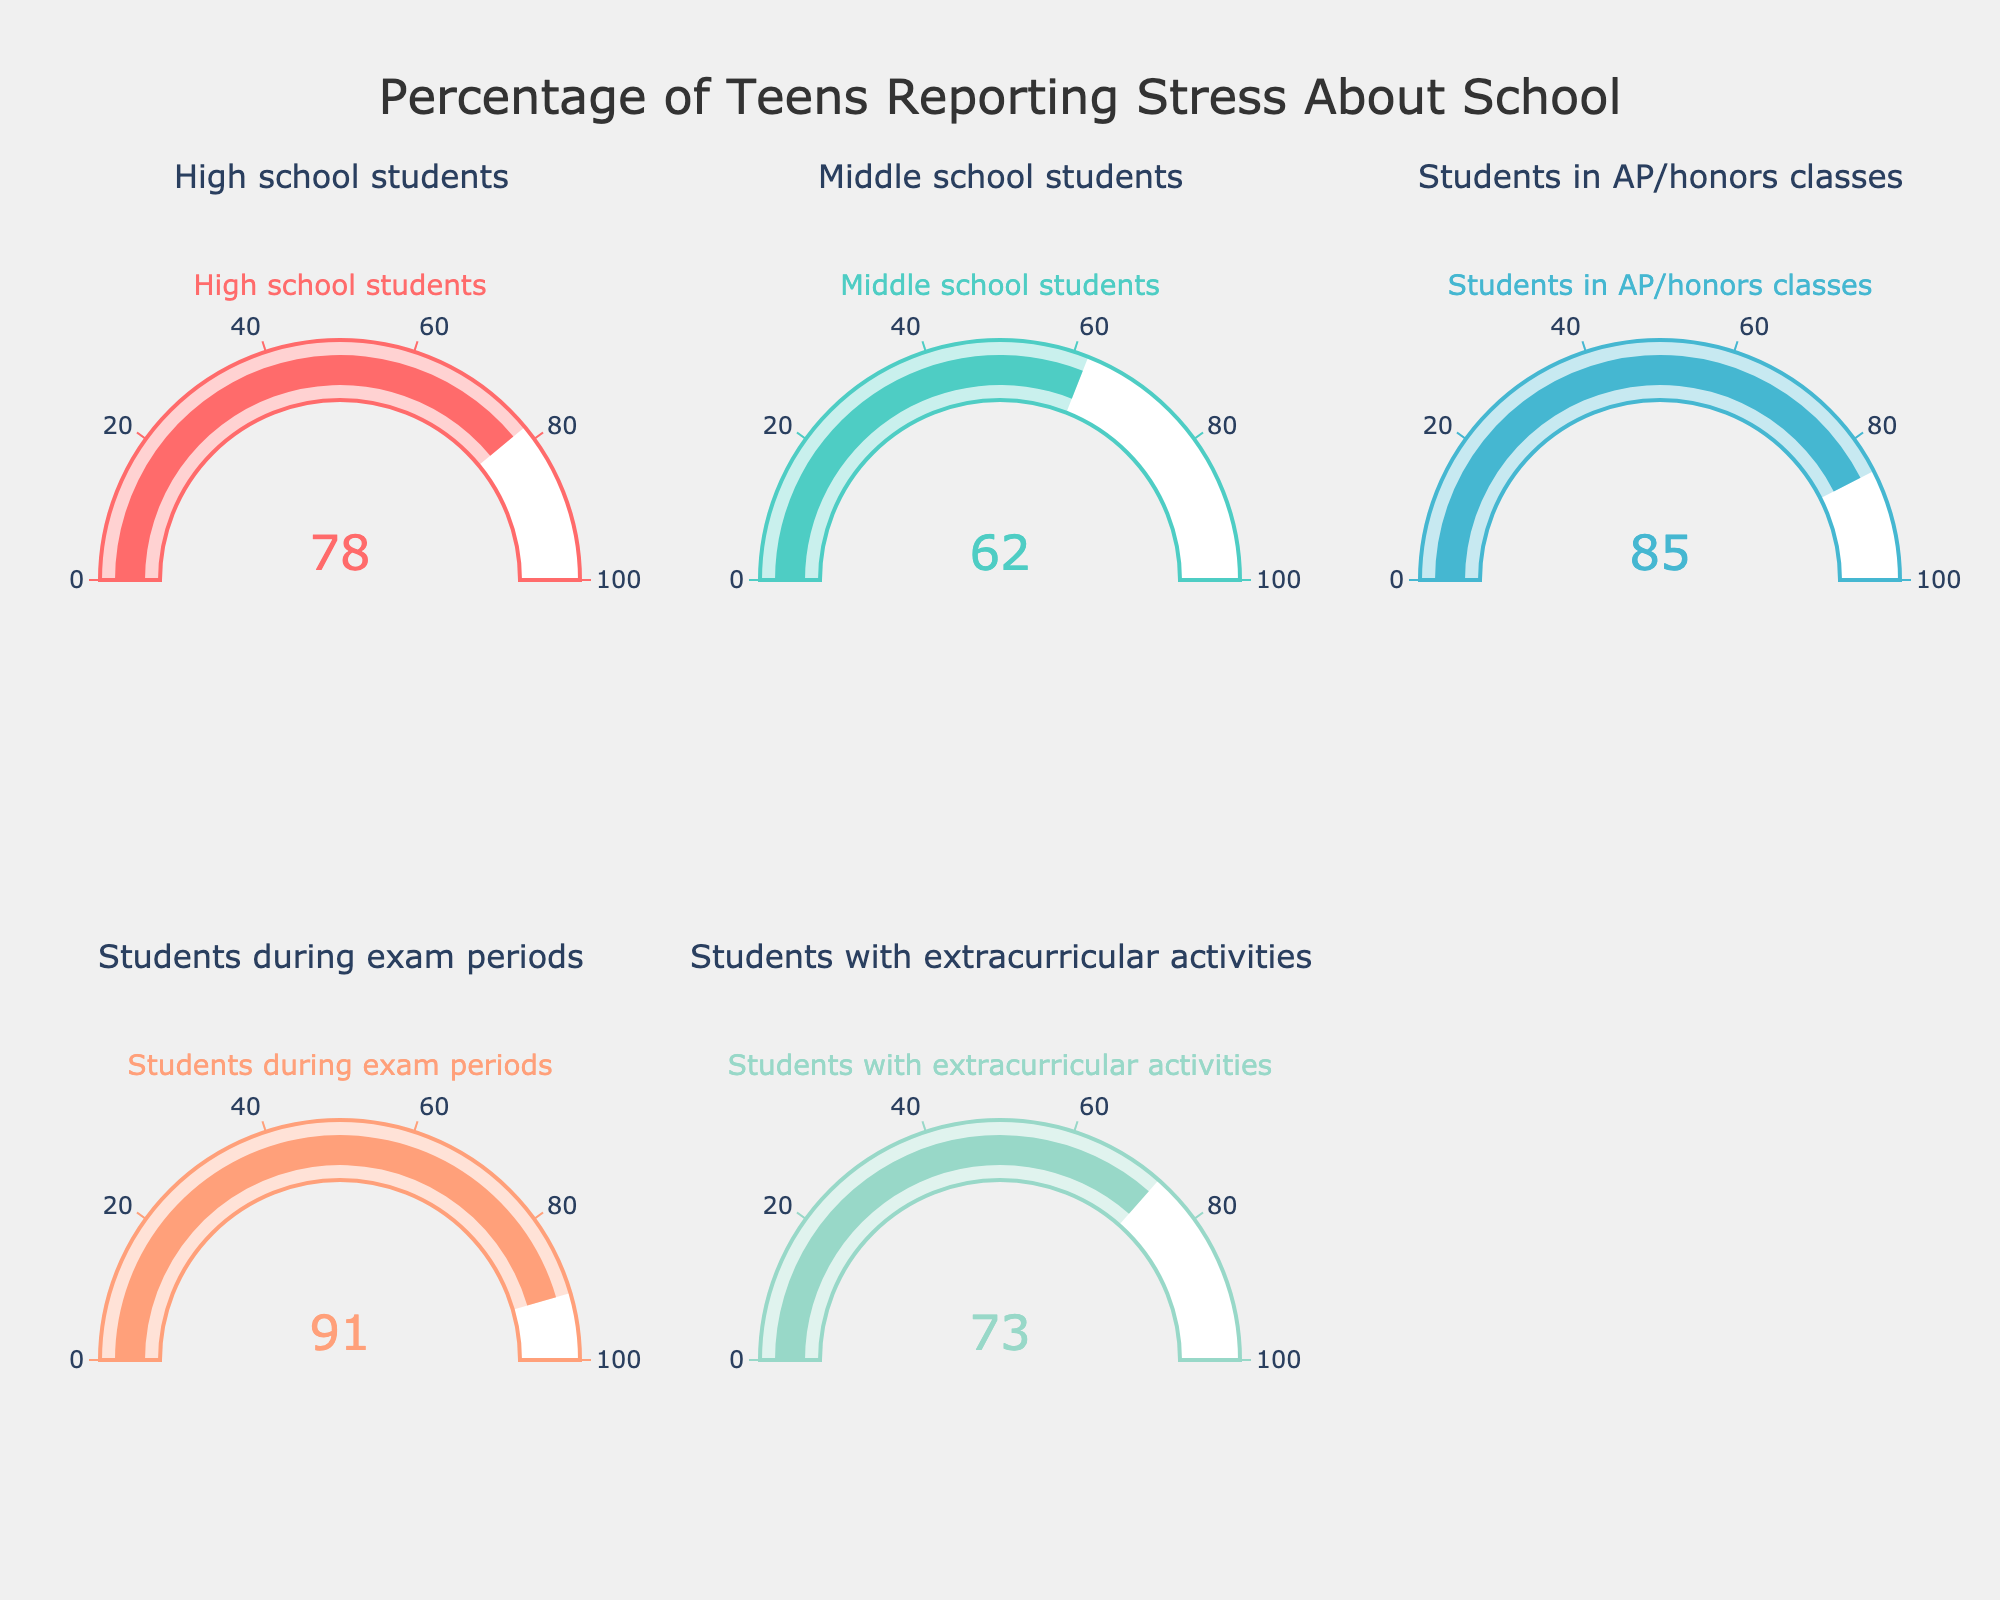what percentage of high school students report feeling stressed about school? The gauge chart for high school students shows a value indicating the percentage of students who report feeling stressed.
Answer: 78% what is the average percentage of teens feeling stressed during exam periods, in AP/honors classes, and with extracurricular activities? To find the average, sum the percentages for these categories and divide by the number of categories. (91 + 85 + 73) / 3 = 249 / 3 = 83
Answer: 83 which group reports the highest percentage of stress about school? The gauge for the group with the highest value indicates 91%, which is for students during exam periods.
Answer: students during exam periods is there a notable difference in stress levels between middle school students and high school students? Subtract the percentage of middle school students from that of high school students (78 - 62). The difference is 16%.
Answer: yes, 16% are students in AP/honors classes more stressed than students with extracurricular activities? Compare the values for AP/honors classes (85%) and students with extracurricular activities (73%). The percentage for AP/honors classes is higher.
Answer: yes how much more stressed are students during exam periods compared to middle school students? Subtract the percentage for middle school students from that of students during exam periods (91 - 62). The difference is 29%.
Answer: 29% which gauge chart has the smallest percentage of stressed teens? The gauge chart with the lowest value indicates 62%, which is for middle school students.
Answer: middle school students 